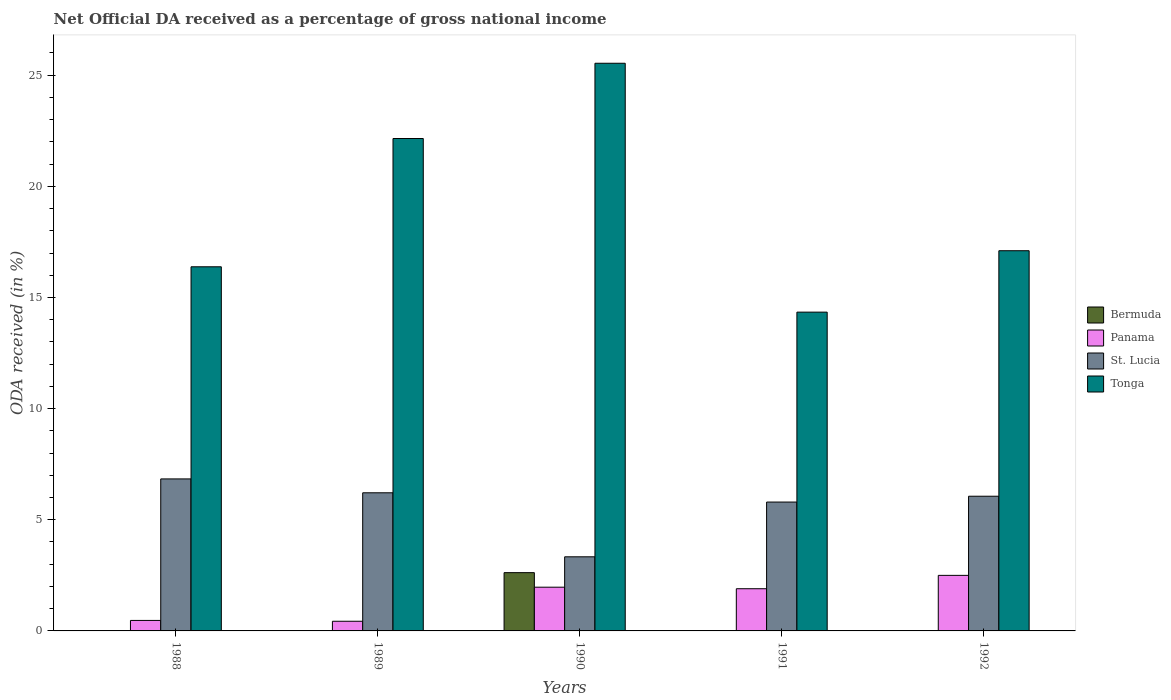How many different coloured bars are there?
Your answer should be very brief. 4. Are the number of bars on each tick of the X-axis equal?
Provide a succinct answer. No. How many bars are there on the 2nd tick from the left?
Give a very brief answer. 4. How many bars are there on the 5th tick from the right?
Keep it short and to the point. 4. What is the label of the 3rd group of bars from the left?
Your answer should be very brief. 1990. What is the net official DA received in Tonga in 1991?
Your response must be concise. 14.34. Across all years, what is the maximum net official DA received in Tonga?
Offer a very short reply. 25.54. Across all years, what is the minimum net official DA received in Tonga?
Keep it short and to the point. 14.34. In which year was the net official DA received in St. Lucia maximum?
Provide a short and direct response. 1988. What is the total net official DA received in St. Lucia in the graph?
Your answer should be compact. 28.24. What is the difference between the net official DA received in Tonga in 1990 and that in 1992?
Your response must be concise. 8.43. What is the difference between the net official DA received in Bermuda in 1988 and the net official DA received in Tonga in 1990?
Provide a short and direct response. -25.53. What is the average net official DA received in St. Lucia per year?
Make the answer very short. 5.65. In the year 1992, what is the difference between the net official DA received in Tonga and net official DA received in Panama?
Give a very brief answer. 14.6. What is the ratio of the net official DA received in Tonga in 1989 to that in 1991?
Make the answer very short. 1.54. Is the difference between the net official DA received in Tonga in 1991 and 1992 greater than the difference between the net official DA received in Panama in 1991 and 1992?
Give a very brief answer. No. What is the difference between the highest and the second highest net official DA received in Panama?
Your answer should be compact. 0.53. What is the difference between the highest and the lowest net official DA received in Bermuda?
Offer a very short reply. 2.62. Is it the case that in every year, the sum of the net official DA received in Panama and net official DA received in Tonga is greater than the sum of net official DA received in St. Lucia and net official DA received in Bermuda?
Make the answer very short. Yes. Is it the case that in every year, the sum of the net official DA received in St. Lucia and net official DA received in Bermuda is greater than the net official DA received in Tonga?
Provide a succinct answer. No. How many years are there in the graph?
Provide a succinct answer. 5. What is the difference between two consecutive major ticks on the Y-axis?
Give a very brief answer. 5. How many legend labels are there?
Ensure brevity in your answer.  4. How are the legend labels stacked?
Your answer should be very brief. Vertical. What is the title of the graph?
Provide a short and direct response. Net Official DA received as a percentage of gross national income. What is the label or title of the X-axis?
Keep it short and to the point. Years. What is the label or title of the Y-axis?
Give a very brief answer. ODA received (in %). What is the ODA received (in %) of Bermuda in 1988?
Make the answer very short. 0. What is the ODA received (in %) of Panama in 1988?
Give a very brief answer. 0.47. What is the ODA received (in %) of St. Lucia in 1988?
Keep it short and to the point. 6.84. What is the ODA received (in %) in Tonga in 1988?
Provide a succinct answer. 16.38. What is the ODA received (in %) in Bermuda in 1989?
Make the answer very short. 0.01. What is the ODA received (in %) of Panama in 1989?
Make the answer very short. 0.43. What is the ODA received (in %) of St. Lucia in 1989?
Offer a very short reply. 6.21. What is the ODA received (in %) of Tonga in 1989?
Offer a terse response. 22.15. What is the ODA received (in %) in Bermuda in 1990?
Provide a short and direct response. 2.62. What is the ODA received (in %) of Panama in 1990?
Offer a very short reply. 1.97. What is the ODA received (in %) in St. Lucia in 1990?
Provide a succinct answer. 3.33. What is the ODA received (in %) of Tonga in 1990?
Provide a short and direct response. 25.54. What is the ODA received (in %) in Bermuda in 1991?
Offer a terse response. 0. What is the ODA received (in %) in Panama in 1991?
Keep it short and to the point. 1.9. What is the ODA received (in %) of St. Lucia in 1991?
Provide a short and direct response. 5.8. What is the ODA received (in %) of Tonga in 1991?
Offer a very short reply. 14.34. What is the ODA received (in %) of Panama in 1992?
Ensure brevity in your answer.  2.5. What is the ODA received (in %) in St. Lucia in 1992?
Give a very brief answer. 6.06. What is the ODA received (in %) in Tonga in 1992?
Your answer should be very brief. 17.1. Across all years, what is the maximum ODA received (in %) in Bermuda?
Keep it short and to the point. 2.62. Across all years, what is the maximum ODA received (in %) of Panama?
Ensure brevity in your answer.  2.5. Across all years, what is the maximum ODA received (in %) in St. Lucia?
Keep it short and to the point. 6.84. Across all years, what is the maximum ODA received (in %) in Tonga?
Your answer should be very brief. 25.54. Across all years, what is the minimum ODA received (in %) in Bermuda?
Keep it short and to the point. 0. Across all years, what is the minimum ODA received (in %) of Panama?
Provide a short and direct response. 0.43. Across all years, what is the minimum ODA received (in %) of St. Lucia?
Your response must be concise. 3.33. Across all years, what is the minimum ODA received (in %) in Tonga?
Give a very brief answer. 14.34. What is the total ODA received (in %) in Bermuda in the graph?
Provide a succinct answer. 2.63. What is the total ODA received (in %) of Panama in the graph?
Give a very brief answer. 7.27. What is the total ODA received (in %) in St. Lucia in the graph?
Ensure brevity in your answer.  28.24. What is the total ODA received (in %) of Tonga in the graph?
Make the answer very short. 95.51. What is the difference between the ODA received (in %) in Bermuda in 1988 and that in 1989?
Provide a short and direct response. -0. What is the difference between the ODA received (in %) of Panama in 1988 and that in 1989?
Provide a succinct answer. 0.04. What is the difference between the ODA received (in %) in St. Lucia in 1988 and that in 1989?
Your response must be concise. 0.62. What is the difference between the ODA received (in %) of Tonga in 1988 and that in 1989?
Your answer should be compact. -5.77. What is the difference between the ODA received (in %) in Bermuda in 1988 and that in 1990?
Provide a succinct answer. -2.62. What is the difference between the ODA received (in %) of Panama in 1988 and that in 1990?
Ensure brevity in your answer.  -1.49. What is the difference between the ODA received (in %) of St. Lucia in 1988 and that in 1990?
Offer a very short reply. 3.5. What is the difference between the ODA received (in %) of Tonga in 1988 and that in 1990?
Keep it short and to the point. -9.16. What is the difference between the ODA received (in %) in Panama in 1988 and that in 1991?
Give a very brief answer. -1.43. What is the difference between the ODA received (in %) of St. Lucia in 1988 and that in 1991?
Provide a short and direct response. 1.04. What is the difference between the ODA received (in %) in Tonga in 1988 and that in 1991?
Offer a terse response. 2.04. What is the difference between the ODA received (in %) in Panama in 1988 and that in 1992?
Your answer should be compact. -2.03. What is the difference between the ODA received (in %) in St. Lucia in 1988 and that in 1992?
Offer a very short reply. 0.78. What is the difference between the ODA received (in %) in Tonga in 1988 and that in 1992?
Your answer should be compact. -0.72. What is the difference between the ODA received (in %) in Bermuda in 1989 and that in 1990?
Your response must be concise. -2.61. What is the difference between the ODA received (in %) of Panama in 1989 and that in 1990?
Your answer should be very brief. -1.53. What is the difference between the ODA received (in %) of St. Lucia in 1989 and that in 1990?
Make the answer very short. 2.88. What is the difference between the ODA received (in %) of Tonga in 1989 and that in 1990?
Keep it short and to the point. -3.39. What is the difference between the ODA received (in %) of Panama in 1989 and that in 1991?
Provide a short and direct response. -1.46. What is the difference between the ODA received (in %) of St. Lucia in 1989 and that in 1991?
Provide a short and direct response. 0.42. What is the difference between the ODA received (in %) in Tonga in 1989 and that in 1991?
Your response must be concise. 7.81. What is the difference between the ODA received (in %) in Panama in 1989 and that in 1992?
Your answer should be very brief. -2.06. What is the difference between the ODA received (in %) of St. Lucia in 1989 and that in 1992?
Your answer should be very brief. 0.15. What is the difference between the ODA received (in %) of Tonga in 1989 and that in 1992?
Your answer should be compact. 5.05. What is the difference between the ODA received (in %) of Panama in 1990 and that in 1991?
Ensure brevity in your answer.  0.07. What is the difference between the ODA received (in %) in St. Lucia in 1990 and that in 1991?
Offer a terse response. -2.46. What is the difference between the ODA received (in %) of Tonga in 1990 and that in 1991?
Your response must be concise. 11.2. What is the difference between the ODA received (in %) in Panama in 1990 and that in 1992?
Your response must be concise. -0.53. What is the difference between the ODA received (in %) of St. Lucia in 1990 and that in 1992?
Provide a short and direct response. -2.73. What is the difference between the ODA received (in %) in Tonga in 1990 and that in 1992?
Keep it short and to the point. 8.43. What is the difference between the ODA received (in %) in Panama in 1991 and that in 1992?
Your response must be concise. -0.6. What is the difference between the ODA received (in %) in St. Lucia in 1991 and that in 1992?
Your answer should be compact. -0.26. What is the difference between the ODA received (in %) in Tonga in 1991 and that in 1992?
Offer a terse response. -2.76. What is the difference between the ODA received (in %) of Bermuda in 1988 and the ODA received (in %) of Panama in 1989?
Your answer should be very brief. -0.43. What is the difference between the ODA received (in %) of Bermuda in 1988 and the ODA received (in %) of St. Lucia in 1989?
Make the answer very short. -6.21. What is the difference between the ODA received (in %) of Bermuda in 1988 and the ODA received (in %) of Tonga in 1989?
Offer a very short reply. -22.15. What is the difference between the ODA received (in %) of Panama in 1988 and the ODA received (in %) of St. Lucia in 1989?
Keep it short and to the point. -5.74. What is the difference between the ODA received (in %) in Panama in 1988 and the ODA received (in %) in Tonga in 1989?
Your response must be concise. -21.68. What is the difference between the ODA received (in %) of St. Lucia in 1988 and the ODA received (in %) of Tonga in 1989?
Your answer should be very brief. -15.31. What is the difference between the ODA received (in %) in Bermuda in 1988 and the ODA received (in %) in Panama in 1990?
Offer a terse response. -1.96. What is the difference between the ODA received (in %) of Bermuda in 1988 and the ODA received (in %) of St. Lucia in 1990?
Offer a very short reply. -3.33. What is the difference between the ODA received (in %) of Bermuda in 1988 and the ODA received (in %) of Tonga in 1990?
Offer a very short reply. -25.53. What is the difference between the ODA received (in %) in Panama in 1988 and the ODA received (in %) in St. Lucia in 1990?
Ensure brevity in your answer.  -2.86. What is the difference between the ODA received (in %) of Panama in 1988 and the ODA received (in %) of Tonga in 1990?
Your answer should be very brief. -25.06. What is the difference between the ODA received (in %) of St. Lucia in 1988 and the ODA received (in %) of Tonga in 1990?
Offer a very short reply. -18.7. What is the difference between the ODA received (in %) in Bermuda in 1988 and the ODA received (in %) in Panama in 1991?
Offer a terse response. -1.9. What is the difference between the ODA received (in %) of Bermuda in 1988 and the ODA received (in %) of St. Lucia in 1991?
Keep it short and to the point. -5.79. What is the difference between the ODA received (in %) of Bermuda in 1988 and the ODA received (in %) of Tonga in 1991?
Provide a succinct answer. -14.34. What is the difference between the ODA received (in %) of Panama in 1988 and the ODA received (in %) of St. Lucia in 1991?
Your answer should be compact. -5.32. What is the difference between the ODA received (in %) in Panama in 1988 and the ODA received (in %) in Tonga in 1991?
Ensure brevity in your answer.  -13.87. What is the difference between the ODA received (in %) of St. Lucia in 1988 and the ODA received (in %) of Tonga in 1991?
Make the answer very short. -7.5. What is the difference between the ODA received (in %) in Bermuda in 1988 and the ODA received (in %) in Panama in 1992?
Your answer should be compact. -2.5. What is the difference between the ODA received (in %) of Bermuda in 1988 and the ODA received (in %) of St. Lucia in 1992?
Keep it short and to the point. -6.06. What is the difference between the ODA received (in %) in Bermuda in 1988 and the ODA received (in %) in Tonga in 1992?
Keep it short and to the point. -17.1. What is the difference between the ODA received (in %) of Panama in 1988 and the ODA received (in %) of St. Lucia in 1992?
Make the answer very short. -5.59. What is the difference between the ODA received (in %) in Panama in 1988 and the ODA received (in %) in Tonga in 1992?
Ensure brevity in your answer.  -16.63. What is the difference between the ODA received (in %) of St. Lucia in 1988 and the ODA received (in %) of Tonga in 1992?
Give a very brief answer. -10.26. What is the difference between the ODA received (in %) of Bermuda in 1989 and the ODA received (in %) of Panama in 1990?
Your answer should be very brief. -1.96. What is the difference between the ODA received (in %) of Bermuda in 1989 and the ODA received (in %) of St. Lucia in 1990?
Offer a very short reply. -3.33. What is the difference between the ODA received (in %) in Bermuda in 1989 and the ODA received (in %) in Tonga in 1990?
Provide a succinct answer. -25.53. What is the difference between the ODA received (in %) of Panama in 1989 and the ODA received (in %) of St. Lucia in 1990?
Keep it short and to the point. -2.9. What is the difference between the ODA received (in %) of Panama in 1989 and the ODA received (in %) of Tonga in 1990?
Your answer should be very brief. -25.1. What is the difference between the ODA received (in %) of St. Lucia in 1989 and the ODA received (in %) of Tonga in 1990?
Offer a terse response. -19.32. What is the difference between the ODA received (in %) in Bermuda in 1989 and the ODA received (in %) in Panama in 1991?
Your answer should be very brief. -1.89. What is the difference between the ODA received (in %) in Bermuda in 1989 and the ODA received (in %) in St. Lucia in 1991?
Keep it short and to the point. -5.79. What is the difference between the ODA received (in %) in Bermuda in 1989 and the ODA received (in %) in Tonga in 1991?
Your response must be concise. -14.33. What is the difference between the ODA received (in %) in Panama in 1989 and the ODA received (in %) in St. Lucia in 1991?
Give a very brief answer. -5.36. What is the difference between the ODA received (in %) of Panama in 1989 and the ODA received (in %) of Tonga in 1991?
Your response must be concise. -13.91. What is the difference between the ODA received (in %) of St. Lucia in 1989 and the ODA received (in %) of Tonga in 1991?
Make the answer very short. -8.13. What is the difference between the ODA received (in %) in Bermuda in 1989 and the ODA received (in %) in Panama in 1992?
Offer a very short reply. -2.49. What is the difference between the ODA received (in %) of Bermuda in 1989 and the ODA received (in %) of St. Lucia in 1992?
Keep it short and to the point. -6.05. What is the difference between the ODA received (in %) in Bermuda in 1989 and the ODA received (in %) in Tonga in 1992?
Provide a short and direct response. -17.1. What is the difference between the ODA received (in %) of Panama in 1989 and the ODA received (in %) of St. Lucia in 1992?
Make the answer very short. -5.62. What is the difference between the ODA received (in %) in Panama in 1989 and the ODA received (in %) in Tonga in 1992?
Offer a very short reply. -16.67. What is the difference between the ODA received (in %) of St. Lucia in 1989 and the ODA received (in %) of Tonga in 1992?
Your answer should be compact. -10.89. What is the difference between the ODA received (in %) in Bermuda in 1990 and the ODA received (in %) in Panama in 1991?
Give a very brief answer. 0.72. What is the difference between the ODA received (in %) of Bermuda in 1990 and the ODA received (in %) of St. Lucia in 1991?
Give a very brief answer. -3.18. What is the difference between the ODA received (in %) in Bermuda in 1990 and the ODA received (in %) in Tonga in 1991?
Your answer should be compact. -11.72. What is the difference between the ODA received (in %) of Panama in 1990 and the ODA received (in %) of St. Lucia in 1991?
Keep it short and to the point. -3.83. What is the difference between the ODA received (in %) of Panama in 1990 and the ODA received (in %) of Tonga in 1991?
Your answer should be very brief. -12.37. What is the difference between the ODA received (in %) of St. Lucia in 1990 and the ODA received (in %) of Tonga in 1991?
Offer a very short reply. -11.01. What is the difference between the ODA received (in %) of Bermuda in 1990 and the ODA received (in %) of Panama in 1992?
Keep it short and to the point. 0.12. What is the difference between the ODA received (in %) in Bermuda in 1990 and the ODA received (in %) in St. Lucia in 1992?
Your response must be concise. -3.44. What is the difference between the ODA received (in %) in Bermuda in 1990 and the ODA received (in %) in Tonga in 1992?
Make the answer very short. -14.48. What is the difference between the ODA received (in %) of Panama in 1990 and the ODA received (in %) of St. Lucia in 1992?
Ensure brevity in your answer.  -4.09. What is the difference between the ODA received (in %) of Panama in 1990 and the ODA received (in %) of Tonga in 1992?
Keep it short and to the point. -15.14. What is the difference between the ODA received (in %) of St. Lucia in 1990 and the ODA received (in %) of Tonga in 1992?
Your answer should be compact. -13.77. What is the difference between the ODA received (in %) of Panama in 1991 and the ODA received (in %) of St. Lucia in 1992?
Offer a terse response. -4.16. What is the difference between the ODA received (in %) of Panama in 1991 and the ODA received (in %) of Tonga in 1992?
Ensure brevity in your answer.  -15.2. What is the difference between the ODA received (in %) in St. Lucia in 1991 and the ODA received (in %) in Tonga in 1992?
Ensure brevity in your answer.  -11.31. What is the average ODA received (in %) in Bermuda per year?
Provide a succinct answer. 0.53. What is the average ODA received (in %) in Panama per year?
Your answer should be compact. 1.45. What is the average ODA received (in %) in St. Lucia per year?
Ensure brevity in your answer.  5.65. What is the average ODA received (in %) of Tonga per year?
Offer a terse response. 19.1. In the year 1988, what is the difference between the ODA received (in %) of Bermuda and ODA received (in %) of Panama?
Your response must be concise. -0.47. In the year 1988, what is the difference between the ODA received (in %) of Bermuda and ODA received (in %) of St. Lucia?
Provide a short and direct response. -6.84. In the year 1988, what is the difference between the ODA received (in %) of Bermuda and ODA received (in %) of Tonga?
Keep it short and to the point. -16.38. In the year 1988, what is the difference between the ODA received (in %) of Panama and ODA received (in %) of St. Lucia?
Your response must be concise. -6.37. In the year 1988, what is the difference between the ODA received (in %) of Panama and ODA received (in %) of Tonga?
Provide a succinct answer. -15.91. In the year 1988, what is the difference between the ODA received (in %) in St. Lucia and ODA received (in %) in Tonga?
Your answer should be compact. -9.54. In the year 1989, what is the difference between the ODA received (in %) in Bermuda and ODA received (in %) in Panama?
Offer a very short reply. -0.43. In the year 1989, what is the difference between the ODA received (in %) of Bermuda and ODA received (in %) of St. Lucia?
Provide a succinct answer. -6.21. In the year 1989, what is the difference between the ODA received (in %) of Bermuda and ODA received (in %) of Tonga?
Your response must be concise. -22.14. In the year 1989, what is the difference between the ODA received (in %) in Panama and ODA received (in %) in St. Lucia?
Your answer should be compact. -5.78. In the year 1989, what is the difference between the ODA received (in %) in Panama and ODA received (in %) in Tonga?
Ensure brevity in your answer.  -21.72. In the year 1989, what is the difference between the ODA received (in %) in St. Lucia and ODA received (in %) in Tonga?
Make the answer very short. -15.94. In the year 1990, what is the difference between the ODA received (in %) of Bermuda and ODA received (in %) of Panama?
Offer a terse response. 0.65. In the year 1990, what is the difference between the ODA received (in %) of Bermuda and ODA received (in %) of St. Lucia?
Provide a succinct answer. -0.71. In the year 1990, what is the difference between the ODA received (in %) of Bermuda and ODA received (in %) of Tonga?
Offer a very short reply. -22.91. In the year 1990, what is the difference between the ODA received (in %) of Panama and ODA received (in %) of St. Lucia?
Ensure brevity in your answer.  -1.37. In the year 1990, what is the difference between the ODA received (in %) in Panama and ODA received (in %) in Tonga?
Your answer should be very brief. -23.57. In the year 1990, what is the difference between the ODA received (in %) in St. Lucia and ODA received (in %) in Tonga?
Give a very brief answer. -22.2. In the year 1991, what is the difference between the ODA received (in %) in Panama and ODA received (in %) in St. Lucia?
Keep it short and to the point. -3.9. In the year 1991, what is the difference between the ODA received (in %) in Panama and ODA received (in %) in Tonga?
Offer a terse response. -12.44. In the year 1991, what is the difference between the ODA received (in %) in St. Lucia and ODA received (in %) in Tonga?
Your answer should be very brief. -8.54. In the year 1992, what is the difference between the ODA received (in %) in Panama and ODA received (in %) in St. Lucia?
Give a very brief answer. -3.56. In the year 1992, what is the difference between the ODA received (in %) in Panama and ODA received (in %) in Tonga?
Ensure brevity in your answer.  -14.6. In the year 1992, what is the difference between the ODA received (in %) in St. Lucia and ODA received (in %) in Tonga?
Offer a terse response. -11.04. What is the ratio of the ODA received (in %) of Bermuda in 1988 to that in 1989?
Your answer should be very brief. 0.42. What is the ratio of the ODA received (in %) of Panama in 1988 to that in 1989?
Offer a very short reply. 1.09. What is the ratio of the ODA received (in %) in St. Lucia in 1988 to that in 1989?
Your answer should be compact. 1.1. What is the ratio of the ODA received (in %) in Tonga in 1988 to that in 1989?
Your response must be concise. 0.74. What is the ratio of the ODA received (in %) in Bermuda in 1988 to that in 1990?
Make the answer very short. 0. What is the ratio of the ODA received (in %) in Panama in 1988 to that in 1990?
Make the answer very short. 0.24. What is the ratio of the ODA received (in %) of St. Lucia in 1988 to that in 1990?
Keep it short and to the point. 2.05. What is the ratio of the ODA received (in %) of Tonga in 1988 to that in 1990?
Your answer should be very brief. 0.64. What is the ratio of the ODA received (in %) of Panama in 1988 to that in 1991?
Make the answer very short. 0.25. What is the ratio of the ODA received (in %) of St. Lucia in 1988 to that in 1991?
Your answer should be very brief. 1.18. What is the ratio of the ODA received (in %) in Tonga in 1988 to that in 1991?
Make the answer very short. 1.14. What is the ratio of the ODA received (in %) of Panama in 1988 to that in 1992?
Your response must be concise. 0.19. What is the ratio of the ODA received (in %) of St. Lucia in 1988 to that in 1992?
Provide a short and direct response. 1.13. What is the ratio of the ODA received (in %) in Tonga in 1988 to that in 1992?
Your answer should be compact. 0.96. What is the ratio of the ODA received (in %) of Bermuda in 1989 to that in 1990?
Provide a short and direct response. 0. What is the ratio of the ODA received (in %) in Panama in 1989 to that in 1990?
Make the answer very short. 0.22. What is the ratio of the ODA received (in %) of St. Lucia in 1989 to that in 1990?
Ensure brevity in your answer.  1.86. What is the ratio of the ODA received (in %) of Tonga in 1989 to that in 1990?
Give a very brief answer. 0.87. What is the ratio of the ODA received (in %) in Panama in 1989 to that in 1991?
Ensure brevity in your answer.  0.23. What is the ratio of the ODA received (in %) of St. Lucia in 1989 to that in 1991?
Make the answer very short. 1.07. What is the ratio of the ODA received (in %) of Tonga in 1989 to that in 1991?
Your answer should be very brief. 1.54. What is the ratio of the ODA received (in %) of Panama in 1989 to that in 1992?
Keep it short and to the point. 0.17. What is the ratio of the ODA received (in %) in St. Lucia in 1989 to that in 1992?
Make the answer very short. 1.03. What is the ratio of the ODA received (in %) in Tonga in 1989 to that in 1992?
Provide a succinct answer. 1.3. What is the ratio of the ODA received (in %) of Panama in 1990 to that in 1991?
Keep it short and to the point. 1.04. What is the ratio of the ODA received (in %) of St. Lucia in 1990 to that in 1991?
Your response must be concise. 0.58. What is the ratio of the ODA received (in %) of Tonga in 1990 to that in 1991?
Provide a succinct answer. 1.78. What is the ratio of the ODA received (in %) in Panama in 1990 to that in 1992?
Your answer should be compact. 0.79. What is the ratio of the ODA received (in %) of St. Lucia in 1990 to that in 1992?
Offer a very short reply. 0.55. What is the ratio of the ODA received (in %) in Tonga in 1990 to that in 1992?
Ensure brevity in your answer.  1.49. What is the ratio of the ODA received (in %) of Panama in 1991 to that in 1992?
Your response must be concise. 0.76. What is the ratio of the ODA received (in %) of St. Lucia in 1991 to that in 1992?
Ensure brevity in your answer.  0.96. What is the ratio of the ODA received (in %) of Tonga in 1991 to that in 1992?
Offer a terse response. 0.84. What is the difference between the highest and the second highest ODA received (in %) in Bermuda?
Make the answer very short. 2.61. What is the difference between the highest and the second highest ODA received (in %) in Panama?
Offer a very short reply. 0.53. What is the difference between the highest and the second highest ODA received (in %) in St. Lucia?
Ensure brevity in your answer.  0.62. What is the difference between the highest and the second highest ODA received (in %) of Tonga?
Provide a succinct answer. 3.39. What is the difference between the highest and the lowest ODA received (in %) in Bermuda?
Ensure brevity in your answer.  2.62. What is the difference between the highest and the lowest ODA received (in %) in Panama?
Keep it short and to the point. 2.06. What is the difference between the highest and the lowest ODA received (in %) of St. Lucia?
Your answer should be very brief. 3.5. What is the difference between the highest and the lowest ODA received (in %) in Tonga?
Keep it short and to the point. 11.2. 